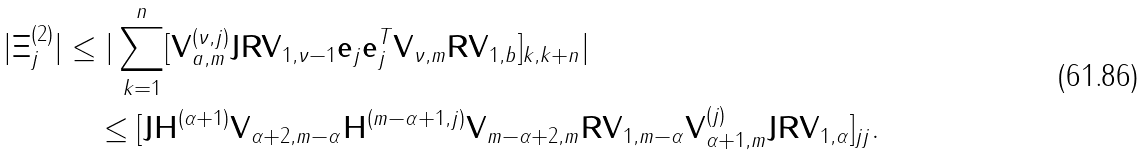Convert formula to latex. <formula><loc_0><loc_0><loc_500><loc_500>| \Xi _ { j } ^ { ( 2 ) } | & \leq | \sum _ { k = 1 } ^ { n } [ \mathbf V ^ { ( \nu , j ) } _ { a , m } \mathbf J \mathbf R \mathbf V _ { 1 , \nu - 1 } \mathbf e _ { j } \mathbf e _ { j } ^ { T } \mathbf V _ { \nu , m } \mathbf R \mathbf V _ { 1 , b } ] _ { k , k + n } | \\ & \quad \leq [ \mathbf J \mathbf H ^ { ( \alpha + 1 ) } \mathbf V _ { \alpha + 2 , m - \alpha } \mathbf H ^ { ( m - \alpha + 1 , j ) } \mathbf V _ { m - \alpha + 2 , m } \mathbf R \mathbf V _ { 1 , m - \alpha } \mathbf V ^ { ( j ) } _ { \alpha + 1 , m } \mathbf J \mathbf R \mathbf V _ { 1 , \alpha } ] _ { j j } .</formula> 